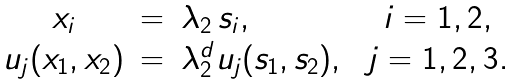Convert formula to latex. <formula><loc_0><loc_0><loc_500><loc_500>\begin{array} { c c l c } x _ { i } & = & \lambda _ { 2 } \, s _ { i } , & \ i = 1 , 2 , \\ u _ { j } ( x _ { 1 } , x _ { 2 } ) & = & \lambda _ { 2 } ^ { d } u _ { j } ( s _ { 1 } , s _ { 2 } ) , & \ j = 1 , 2 , 3 . \end{array}</formula> 